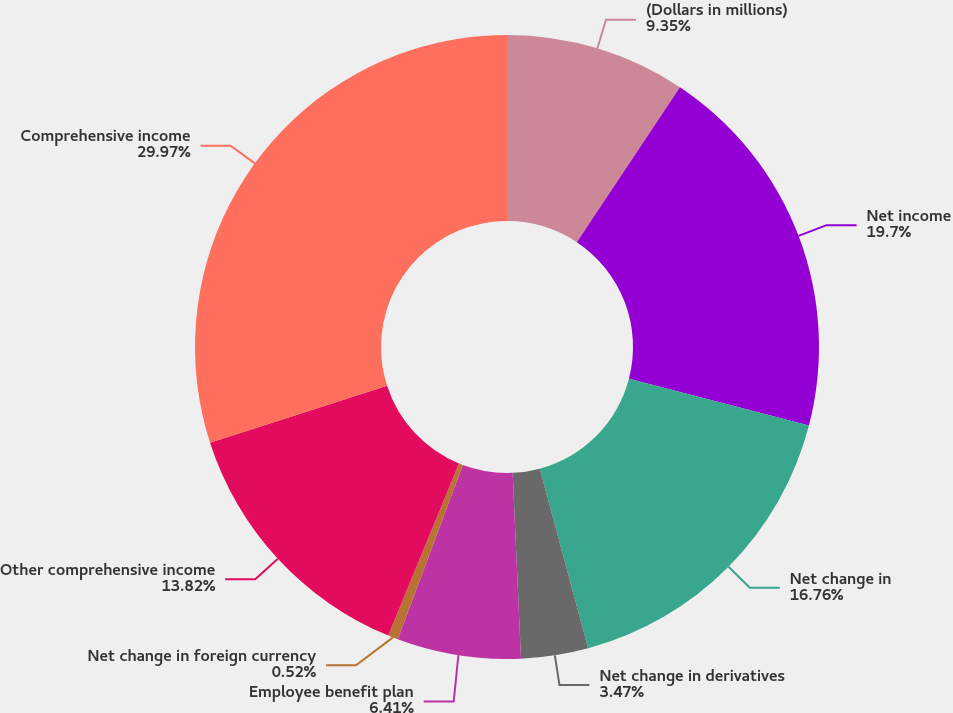Convert chart to OTSL. <chart><loc_0><loc_0><loc_500><loc_500><pie_chart><fcel>(Dollars in millions)<fcel>Net income<fcel>Net change in<fcel>Net change in derivatives<fcel>Employee benefit plan<fcel>Net change in foreign currency<fcel>Other comprehensive income<fcel>Comprehensive income<nl><fcel>9.35%<fcel>19.7%<fcel>16.76%<fcel>3.47%<fcel>6.41%<fcel>0.52%<fcel>13.82%<fcel>29.96%<nl></chart> 